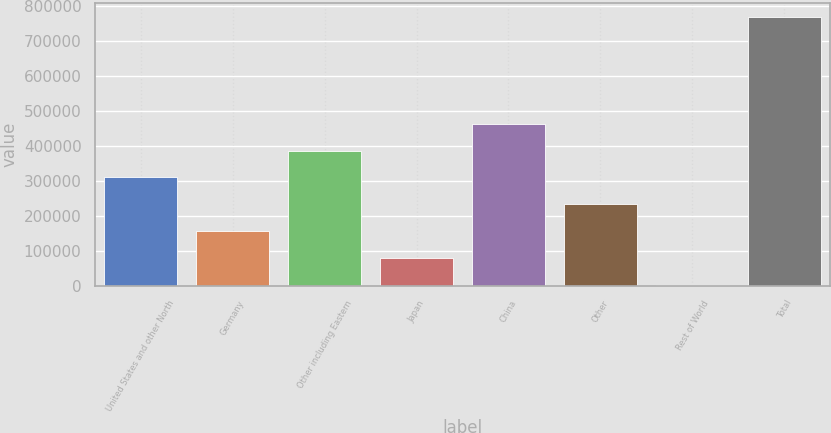<chart> <loc_0><loc_0><loc_500><loc_500><bar_chart><fcel>United States and other North<fcel>Germany<fcel>Other including Eastern<fcel>Japan<fcel>China<fcel>Other<fcel>Rest of World<fcel>Total<nl><fcel>309778<fcel>156427<fcel>386454<fcel>79751.6<fcel>463130<fcel>233103<fcel>3076<fcel>769832<nl></chart> 